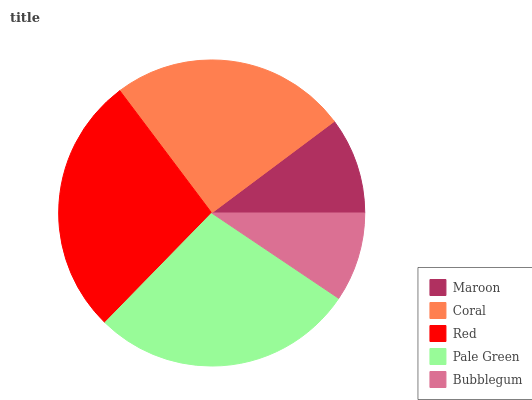Is Bubblegum the minimum?
Answer yes or no. Yes. Is Pale Green the maximum?
Answer yes or no. Yes. Is Coral the minimum?
Answer yes or no. No. Is Coral the maximum?
Answer yes or no. No. Is Coral greater than Maroon?
Answer yes or no. Yes. Is Maroon less than Coral?
Answer yes or no. Yes. Is Maroon greater than Coral?
Answer yes or no. No. Is Coral less than Maroon?
Answer yes or no. No. Is Coral the high median?
Answer yes or no. Yes. Is Coral the low median?
Answer yes or no. Yes. Is Pale Green the high median?
Answer yes or no. No. Is Pale Green the low median?
Answer yes or no. No. 